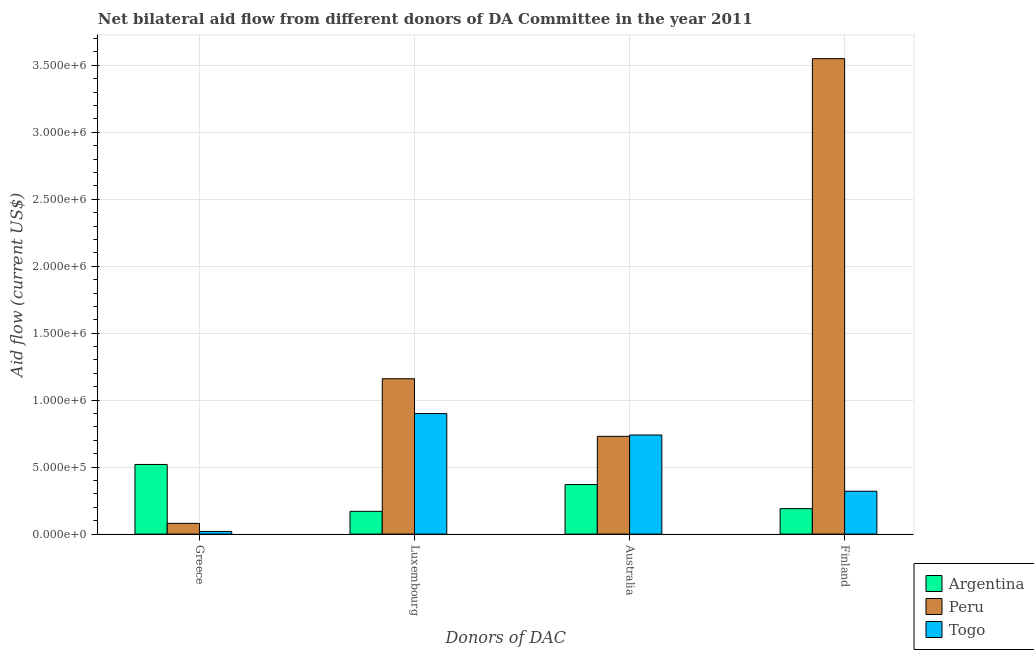How many groups of bars are there?
Offer a very short reply. 4. Are the number of bars on each tick of the X-axis equal?
Provide a short and direct response. Yes. How many bars are there on the 1st tick from the right?
Ensure brevity in your answer.  3. What is the label of the 1st group of bars from the left?
Your answer should be compact. Greece. What is the amount of aid given by finland in Togo?
Your answer should be very brief. 3.20e+05. Across all countries, what is the maximum amount of aid given by finland?
Your response must be concise. 3.55e+06. Across all countries, what is the minimum amount of aid given by greece?
Provide a succinct answer. 2.00e+04. In which country was the amount of aid given by greece maximum?
Offer a terse response. Argentina. What is the total amount of aid given by australia in the graph?
Offer a very short reply. 1.84e+06. What is the difference between the amount of aid given by australia in Peru and that in Argentina?
Make the answer very short. 3.60e+05. What is the difference between the amount of aid given by luxembourg in Togo and the amount of aid given by finland in Argentina?
Your answer should be very brief. 7.10e+05. What is the average amount of aid given by australia per country?
Keep it short and to the point. 6.13e+05. What is the difference between the amount of aid given by luxembourg and amount of aid given by australia in Togo?
Make the answer very short. 1.60e+05. In how many countries, is the amount of aid given by finland greater than 1500000 US$?
Provide a short and direct response. 1. What is the ratio of the amount of aid given by finland in Togo to that in Argentina?
Ensure brevity in your answer.  1.68. Is the difference between the amount of aid given by australia in Togo and Peru greater than the difference between the amount of aid given by finland in Togo and Peru?
Make the answer very short. Yes. What is the difference between the highest and the second highest amount of aid given by australia?
Offer a terse response. 10000. What is the difference between the highest and the lowest amount of aid given by australia?
Your response must be concise. 3.70e+05. In how many countries, is the amount of aid given by australia greater than the average amount of aid given by australia taken over all countries?
Offer a terse response. 2. What does the 3rd bar from the left in Finland represents?
Keep it short and to the point. Togo. What does the 2nd bar from the right in Australia represents?
Offer a terse response. Peru. Are all the bars in the graph horizontal?
Give a very brief answer. No. How many countries are there in the graph?
Ensure brevity in your answer.  3. What is the difference between two consecutive major ticks on the Y-axis?
Ensure brevity in your answer.  5.00e+05. Does the graph contain any zero values?
Offer a very short reply. No. Does the graph contain grids?
Your answer should be very brief. Yes. How many legend labels are there?
Your answer should be compact. 3. How are the legend labels stacked?
Provide a short and direct response. Vertical. What is the title of the graph?
Provide a succinct answer. Net bilateral aid flow from different donors of DA Committee in the year 2011. Does "North America" appear as one of the legend labels in the graph?
Your answer should be very brief. No. What is the label or title of the X-axis?
Your response must be concise. Donors of DAC. What is the Aid flow (current US$) of Argentina in Greece?
Keep it short and to the point. 5.20e+05. What is the Aid flow (current US$) in Togo in Greece?
Make the answer very short. 2.00e+04. What is the Aid flow (current US$) of Argentina in Luxembourg?
Offer a very short reply. 1.70e+05. What is the Aid flow (current US$) of Peru in Luxembourg?
Offer a terse response. 1.16e+06. What is the Aid flow (current US$) in Togo in Luxembourg?
Provide a succinct answer. 9.00e+05. What is the Aid flow (current US$) of Peru in Australia?
Your answer should be compact. 7.30e+05. What is the Aid flow (current US$) in Togo in Australia?
Your answer should be very brief. 7.40e+05. What is the Aid flow (current US$) in Argentina in Finland?
Your answer should be very brief. 1.90e+05. What is the Aid flow (current US$) of Peru in Finland?
Keep it short and to the point. 3.55e+06. Across all Donors of DAC, what is the maximum Aid flow (current US$) in Argentina?
Ensure brevity in your answer.  5.20e+05. Across all Donors of DAC, what is the maximum Aid flow (current US$) in Peru?
Offer a terse response. 3.55e+06. Across all Donors of DAC, what is the minimum Aid flow (current US$) of Peru?
Your answer should be compact. 8.00e+04. Across all Donors of DAC, what is the minimum Aid flow (current US$) of Togo?
Provide a short and direct response. 2.00e+04. What is the total Aid flow (current US$) of Argentina in the graph?
Offer a terse response. 1.25e+06. What is the total Aid flow (current US$) in Peru in the graph?
Offer a very short reply. 5.52e+06. What is the total Aid flow (current US$) in Togo in the graph?
Keep it short and to the point. 1.98e+06. What is the difference between the Aid flow (current US$) of Argentina in Greece and that in Luxembourg?
Your answer should be compact. 3.50e+05. What is the difference between the Aid flow (current US$) in Peru in Greece and that in Luxembourg?
Offer a very short reply. -1.08e+06. What is the difference between the Aid flow (current US$) of Togo in Greece and that in Luxembourg?
Your answer should be compact. -8.80e+05. What is the difference between the Aid flow (current US$) of Argentina in Greece and that in Australia?
Provide a short and direct response. 1.50e+05. What is the difference between the Aid flow (current US$) of Peru in Greece and that in Australia?
Make the answer very short. -6.50e+05. What is the difference between the Aid flow (current US$) of Togo in Greece and that in Australia?
Provide a short and direct response. -7.20e+05. What is the difference between the Aid flow (current US$) of Argentina in Greece and that in Finland?
Provide a succinct answer. 3.30e+05. What is the difference between the Aid flow (current US$) of Peru in Greece and that in Finland?
Provide a short and direct response. -3.47e+06. What is the difference between the Aid flow (current US$) in Argentina in Luxembourg and that in Australia?
Your answer should be very brief. -2.00e+05. What is the difference between the Aid flow (current US$) of Peru in Luxembourg and that in Finland?
Offer a terse response. -2.39e+06. What is the difference between the Aid flow (current US$) in Togo in Luxembourg and that in Finland?
Keep it short and to the point. 5.80e+05. What is the difference between the Aid flow (current US$) of Argentina in Australia and that in Finland?
Offer a very short reply. 1.80e+05. What is the difference between the Aid flow (current US$) in Peru in Australia and that in Finland?
Offer a very short reply. -2.82e+06. What is the difference between the Aid flow (current US$) in Togo in Australia and that in Finland?
Provide a succinct answer. 4.20e+05. What is the difference between the Aid flow (current US$) of Argentina in Greece and the Aid flow (current US$) of Peru in Luxembourg?
Provide a short and direct response. -6.40e+05. What is the difference between the Aid flow (current US$) of Argentina in Greece and the Aid flow (current US$) of Togo in Luxembourg?
Offer a very short reply. -3.80e+05. What is the difference between the Aid flow (current US$) of Peru in Greece and the Aid flow (current US$) of Togo in Luxembourg?
Ensure brevity in your answer.  -8.20e+05. What is the difference between the Aid flow (current US$) in Argentina in Greece and the Aid flow (current US$) in Togo in Australia?
Offer a terse response. -2.20e+05. What is the difference between the Aid flow (current US$) of Peru in Greece and the Aid flow (current US$) of Togo in Australia?
Keep it short and to the point. -6.60e+05. What is the difference between the Aid flow (current US$) of Argentina in Greece and the Aid flow (current US$) of Peru in Finland?
Provide a short and direct response. -3.03e+06. What is the difference between the Aid flow (current US$) of Argentina in Luxembourg and the Aid flow (current US$) of Peru in Australia?
Ensure brevity in your answer.  -5.60e+05. What is the difference between the Aid flow (current US$) in Argentina in Luxembourg and the Aid flow (current US$) in Togo in Australia?
Your answer should be very brief. -5.70e+05. What is the difference between the Aid flow (current US$) in Argentina in Luxembourg and the Aid flow (current US$) in Peru in Finland?
Your answer should be compact. -3.38e+06. What is the difference between the Aid flow (current US$) of Argentina in Luxembourg and the Aid flow (current US$) of Togo in Finland?
Ensure brevity in your answer.  -1.50e+05. What is the difference between the Aid flow (current US$) of Peru in Luxembourg and the Aid flow (current US$) of Togo in Finland?
Give a very brief answer. 8.40e+05. What is the difference between the Aid flow (current US$) of Argentina in Australia and the Aid flow (current US$) of Peru in Finland?
Make the answer very short. -3.18e+06. What is the average Aid flow (current US$) in Argentina per Donors of DAC?
Give a very brief answer. 3.12e+05. What is the average Aid flow (current US$) in Peru per Donors of DAC?
Ensure brevity in your answer.  1.38e+06. What is the average Aid flow (current US$) of Togo per Donors of DAC?
Your answer should be very brief. 4.95e+05. What is the difference between the Aid flow (current US$) of Peru and Aid flow (current US$) of Togo in Greece?
Offer a terse response. 6.00e+04. What is the difference between the Aid flow (current US$) in Argentina and Aid flow (current US$) in Peru in Luxembourg?
Keep it short and to the point. -9.90e+05. What is the difference between the Aid flow (current US$) in Argentina and Aid flow (current US$) in Togo in Luxembourg?
Make the answer very short. -7.30e+05. What is the difference between the Aid flow (current US$) in Argentina and Aid flow (current US$) in Peru in Australia?
Make the answer very short. -3.60e+05. What is the difference between the Aid flow (current US$) in Argentina and Aid flow (current US$) in Togo in Australia?
Keep it short and to the point. -3.70e+05. What is the difference between the Aid flow (current US$) in Argentina and Aid flow (current US$) in Peru in Finland?
Make the answer very short. -3.36e+06. What is the difference between the Aid flow (current US$) in Argentina and Aid flow (current US$) in Togo in Finland?
Your answer should be compact. -1.30e+05. What is the difference between the Aid flow (current US$) of Peru and Aid flow (current US$) of Togo in Finland?
Your answer should be very brief. 3.23e+06. What is the ratio of the Aid flow (current US$) of Argentina in Greece to that in Luxembourg?
Provide a short and direct response. 3.06. What is the ratio of the Aid flow (current US$) in Peru in Greece to that in Luxembourg?
Offer a terse response. 0.07. What is the ratio of the Aid flow (current US$) in Togo in Greece to that in Luxembourg?
Provide a short and direct response. 0.02. What is the ratio of the Aid flow (current US$) of Argentina in Greece to that in Australia?
Offer a terse response. 1.41. What is the ratio of the Aid flow (current US$) in Peru in Greece to that in Australia?
Your response must be concise. 0.11. What is the ratio of the Aid flow (current US$) in Togo in Greece to that in Australia?
Ensure brevity in your answer.  0.03. What is the ratio of the Aid flow (current US$) in Argentina in Greece to that in Finland?
Ensure brevity in your answer.  2.74. What is the ratio of the Aid flow (current US$) in Peru in Greece to that in Finland?
Offer a very short reply. 0.02. What is the ratio of the Aid flow (current US$) of Togo in Greece to that in Finland?
Provide a short and direct response. 0.06. What is the ratio of the Aid flow (current US$) of Argentina in Luxembourg to that in Australia?
Your answer should be very brief. 0.46. What is the ratio of the Aid flow (current US$) of Peru in Luxembourg to that in Australia?
Your answer should be very brief. 1.59. What is the ratio of the Aid flow (current US$) of Togo in Luxembourg to that in Australia?
Make the answer very short. 1.22. What is the ratio of the Aid flow (current US$) in Argentina in Luxembourg to that in Finland?
Your response must be concise. 0.89. What is the ratio of the Aid flow (current US$) in Peru in Luxembourg to that in Finland?
Your answer should be very brief. 0.33. What is the ratio of the Aid flow (current US$) in Togo in Luxembourg to that in Finland?
Your response must be concise. 2.81. What is the ratio of the Aid flow (current US$) in Argentina in Australia to that in Finland?
Provide a succinct answer. 1.95. What is the ratio of the Aid flow (current US$) in Peru in Australia to that in Finland?
Offer a very short reply. 0.21. What is the ratio of the Aid flow (current US$) in Togo in Australia to that in Finland?
Offer a very short reply. 2.31. What is the difference between the highest and the second highest Aid flow (current US$) of Peru?
Keep it short and to the point. 2.39e+06. What is the difference between the highest and the second highest Aid flow (current US$) in Togo?
Make the answer very short. 1.60e+05. What is the difference between the highest and the lowest Aid flow (current US$) in Peru?
Offer a terse response. 3.47e+06. What is the difference between the highest and the lowest Aid flow (current US$) of Togo?
Your answer should be very brief. 8.80e+05. 